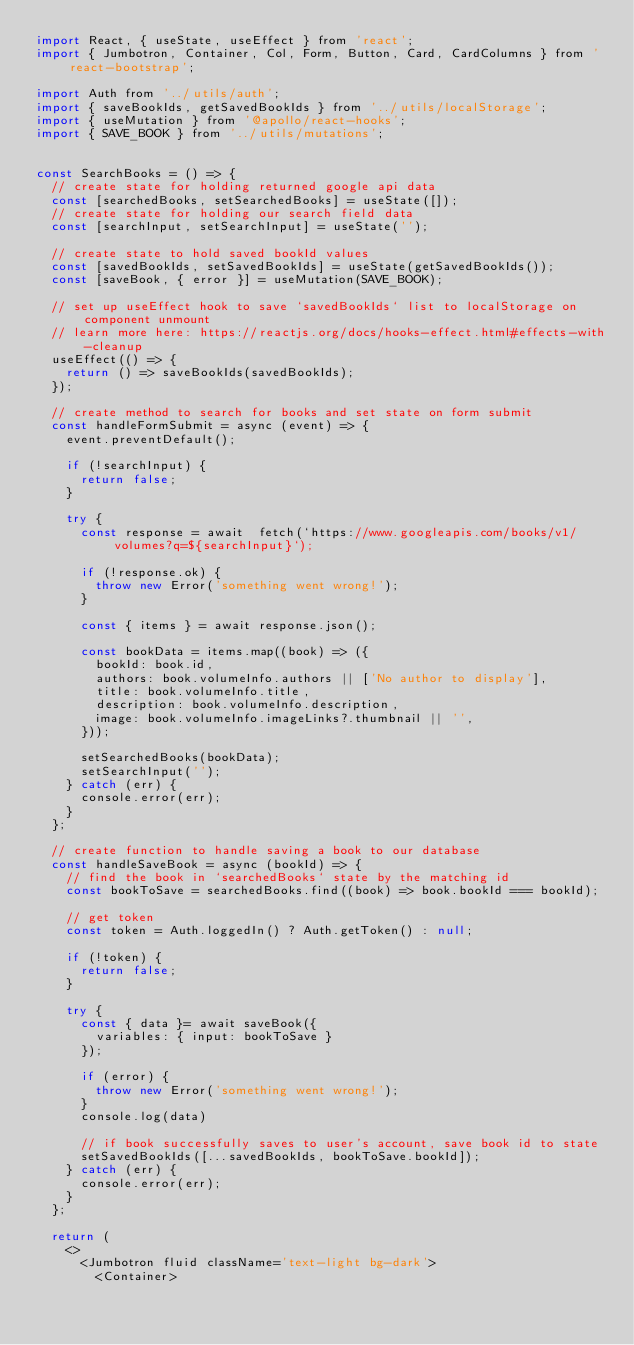Convert code to text. <code><loc_0><loc_0><loc_500><loc_500><_JavaScript_>import React, { useState, useEffect } from 'react';
import { Jumbotron, Container, Col, Form, Button, Card, CardColumns } from 'react-bootstrap';

import Auth from '../utils/auth';
import { saveBookIds, getSavedBookIds } from '../utils/localStorage';
import { useMutation } from '@apollo/react-hooks';
import { SAVE_BOOK } from '../utils/mutations';


const SearchBooks = () => {
  // create state for holding returned google api data
  const [searchedBooks, setSearchedBooks] = useState([]);
  // create state for holding our search field data
  const [searchInput, setSearchInput] = useState('');

  // create state to hold saved bookId values
  const [savedBookIds, setSavedBookIds] = useState(getSavedBookIds());
  const [saveBook, { error }] = useMutation(SAVE_BOOK);

  // set up useEffect hook to save `savedBookIds` list to localStorage on component unmount
  // learn more here: https://reactjs.org/docs/hooks-effect.html#effects-with-cleanup
  useEffect(() => {
    return () => saveBookIds(savedBookIds);
  });

  // create method to search for books and set state on form submit
  const handleFormSubmit = async (event) => {
    event.preventDefault();

    if (!searchInput) {
      return false;
    }

    try {
      const response = await  fetch(`https://www.googleapis.com/books/v1/volumes?q=${searchInput}`);

      if (!response.ok) {
        throw new Error('something went wrong!');
      }

      const { items } = await response.json();

      const bookData = items.map((book) => ({
        bookId: book.id,
        authors: book.volumeInfo.authors || ['No author to display'],
        title: book.volumeInfo.title,
        description: book.volumeInfo.description,
        image: book.volumeInfo.imageLinks?.thumbnail || '',
      }));

      setSearchedBooks(bookData);
      setSearchInput('');
    } catch (err) {
      console.error(err);
    }
  };

  // create function to handle saving a book to our database
  const handleSaveBook = async (bookId) => {
    // find the book in `searchedBooks` state by the matching id
    const bookToSave = searchedBooks.find((book) => book.bookId === bookId);

    // get token
    const token = Auth.loggedIn() ? Auth.getToken() : null;

    if (!token) {
      return false;
    }

    try {
      const { data }= await saveBook({
        variables: { input: bookToSave }
      });

      if (error) {
        throw new Error('something went wrong!');
      }
      console.log(data)

      // if book successfully saves to user's account, save book id to state
      setSavedBookIds([...savedBookIds, bookToSave.bookId]);
    } catch (err) {
      console.error(err);
    }
  };

  return (
    <>
      <Jumbotron fluid className='text-light bg-dark'>
        <Container></code> 